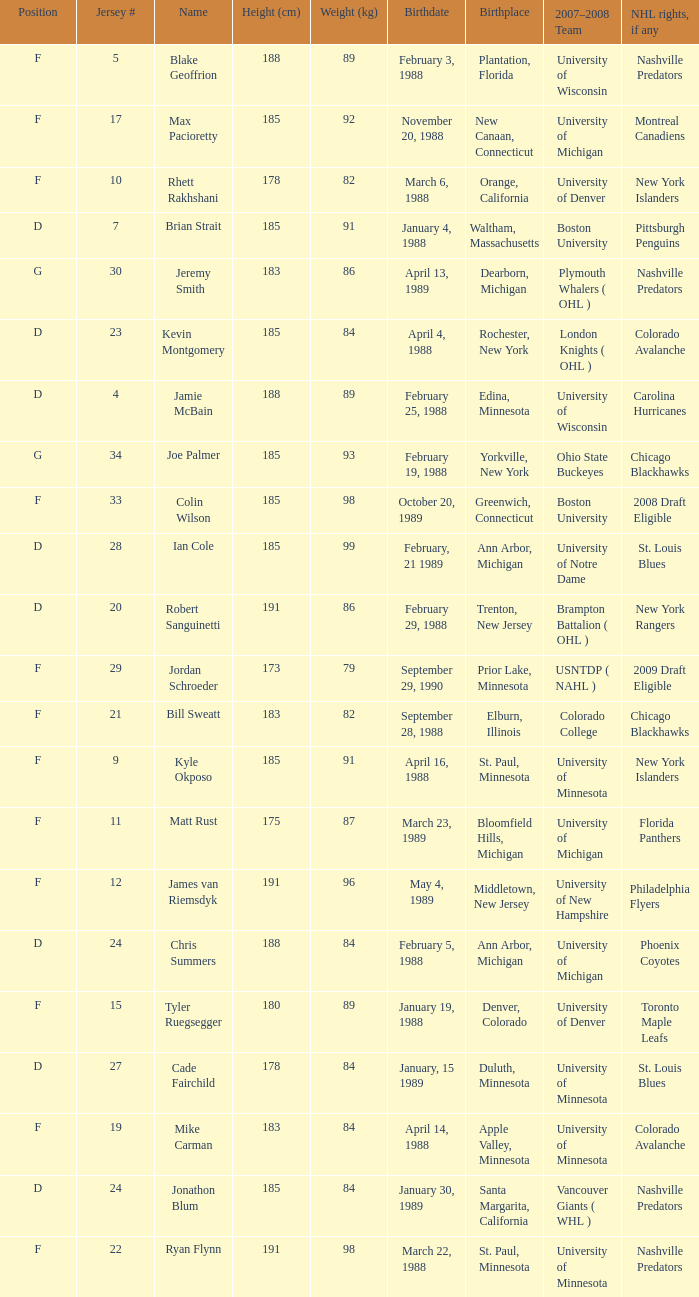Which Height (cm) has a Birthplace of bloomfield hills, michigan? 175.0. 